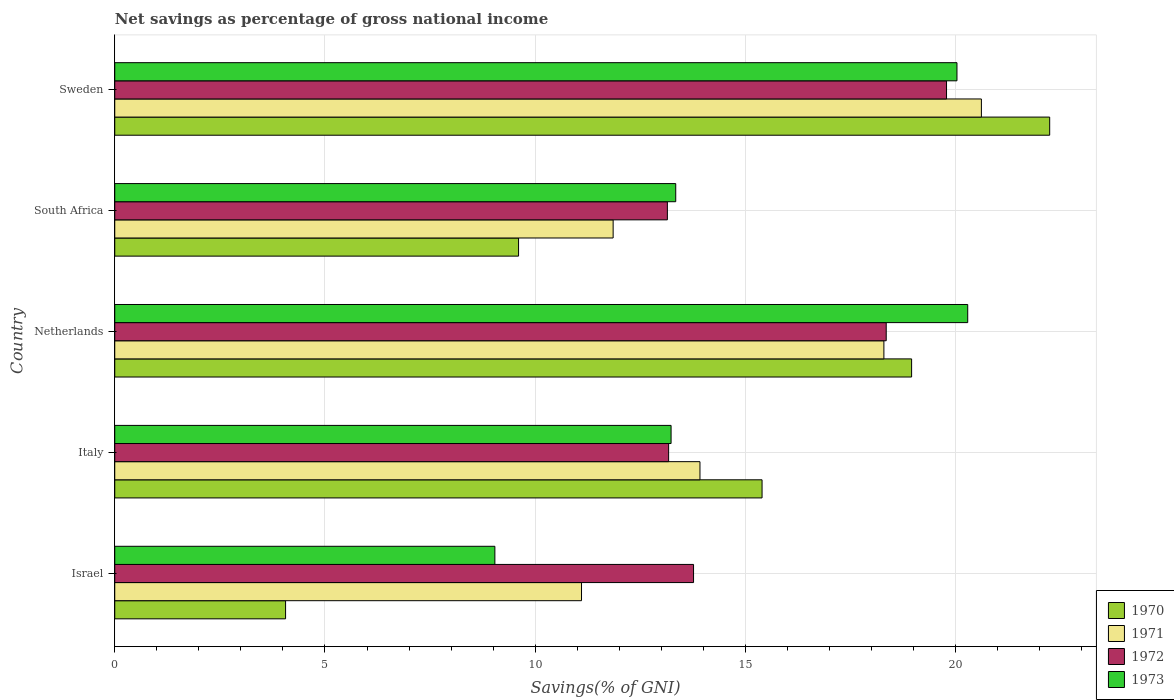How many groups of bars are there?
Your answer should be compact. 5. How many bars are there on the 5th tick from the bottom?
Your response must be concise. 4. What is the label of the 2nd group of bars from the top?
Keep it short and to the point. South Africa. In how many cases, is the number of bars for a given country not equal to the number of legend labels?
Your response must be concise. 0. What is the total savings in 1971 in Sweden?
Offer a very short reply. 20.61. Across all countries, what is the maximum total savings in 1972?
Give a very brief answer. 19.78. Across all countries, what is the minimum total savings in 1973?
Your answer should be very brief. 9.04. What is the total total savings in 1972 in the graph?
Your answer should be very brief. 78.22. What is the difference between the total savings in 1972 in Italy and that in South Africa?
Offer a terse response. 0.03. What is the difference between the total savings in 1972 in Italy and the total savings in 1970 in Israel?
Provide a succinct answer. 9.11. What is the average total savings in 1973 per country?
Ensure brevity in your answer.  15.19. What is the difference between the total savings in 1972 and total savings in 1973 in Italy?
Provide a short and direct response. -0.06. What is the ratio of the total savings in 1971 in Italy to that in Sweden?
Offer a very short reply. 0.68. What is the difference between the highest and the second highest total savings in 1973?
Make the answer very short. 0.26. What is the difference between the highest and the lowest total savings in 1972?
Your response must be concise. 6.64. In how many countries, is the total savings in 1970 greater than the average total savings in 1970 taken over all countries?
Give a very brief answer. 3. Is the sum of the total savings in 1971 in Israel and Italy greater than the maximum total savings in 1973 across all countries?
Keep it short and to the point. Yes. Is it the case that in every country, the sum of the total savings in 1971 and total savings in 1972 is greater than the sum of total savings in 1973 and total savings in 1970?
Offer a very short reply. No. What does the 2nd bar from the top in Netherlands represents?
Your answer should be very brief. 1972. Is it the case that in every country, the sum of the total savings in 1970 and total savings in 1971 is greater than the total savings in 1973?
Provide a succinct answer. Yes. How many bars are there?
Provide a succinct answer. 20. How many countries are there in the graph?
Offer a terse response. 5. Does the graph contain any zero values?
Provide a succinct answer. No. Does the graph contain grids?
Provide a succinct answer. Yes. What is the title of the graph?
Keep it short and to the point. Net savings as percentage of gross national income. Does "1976" appear as one of the legend labels in the graph?
Your answer should be compact. No. What is the label or title of the X-axis?
Your answer should be compact. Savings(% of GNI). What is the Savings(% of GNI) in 1970 in Israel?
Provide a succinct answer. 4.06. What is the Savings(% of GNI) of 1971 in Israel?
Provide a succinct answer. 11.1. What is the Savings(% of GNI) in 1972 in Israel?
Offer a very short reply. 13.77. What is the Savings(% of GNI) in 1973 in Israel?
Your answer should be compact. 9.04. What is the Savings(% of GNI) of 1970 in Italy?
Your answer should be compact. 15.4. What is the Savings(% of GNI) of 1971 in Italy?
Your response must be concise. 13.92. What is the Savings(% of GNI) in 1972 in Italy?
Your answer should be compact. 13.17. What is the Savings(% of GNI) in 1973 in Italy?
Your answer should be compact. 13.23. What is the Savings(% of GNI) of 1970 in Netherlands?
Ensure brevity in your answer.  18.95. What is the Savings(% of GNI) of 1971 in Netherlands?
Provide a succinct answer. 18.29. What is the Savings(% of GNI) of 1972 in Netherlands?
Provide a short and direct response. 18.35. What is the Savings(% of GNI) of 1973 in Netherlands?
Provide a succinct answer. 20.29. What is the Savings(% of GNI) in 1970 in South Africa?
Ensure brevity in your answer.  9.6. What is the Savings(% of GNI) in 1971 in South Africa?
Your answer should be very brief. 11.85. What is the Savings(% of GNI) in 1972 in South Africa?
Provide a short and direct response. 13.14. What is the Savings(% of GNI) in 1973 in South Africa?
Keep it short and to the point. 13.34. What is the Savings(% of GNI) in 1970 in Sweden?
Offer a terse response. 22.24. What is the Savings(% of GNI) in 1971 in Sweden?
Your response must be concise. 20.61. What is the Savings(% of GNI) in 1972 in Sweden?
Provide a succinct answer. 19.78. What is the Savings(% of GNI) of 1973 in Sweden?
Offer a terse response. 20.03. Across all countries, what is the maximum Savings(% of GNI) of 1970?
Give a very brief answer. 22.24. Across all countries, what is the maximum Savings(% of GNI) in 1971?
Your response must be concise. 20.61. Across all countries, what is the maximum Savings(% of GNI) of 1972?
Your answer should be compact. 19.78. Across all countries, what is the maximum Savings(% of GNI) in 1973?
Make the answer very short. 20.29. Across all countries, what is the minimum Savings(% of GNI) of 1970?
Your answer should be compact. 4.06. Across all countries, what is the minimum Savings(% of GNI) in 1971?
Give a very brief answer. 11.1. Across all countries, what is the minimum Savings(% of GNI) in 1972?
Your response must be concise. 13.14. Across all countries, what is the minimum Savings(% of GNI) of 1973?
Keep it short and to the point. 9.04. What is the total Savings(% of GNI) of 1970 in the graph?
Make the answer very short. 70.25. What is the total Savings(% of GNI) of 1971 in the graph?
Provide a short and direct response. 75.78. What is the total Savings(% of GNI) in 1972 in the graph?
Your answer should be compact. 78.22. What is the total Savings(% of GNI) in 1973 in the graph?
Provide a short and direct response. 75.93. What is the difference between the Savings(% of GNI) of 1970 in Israel and that in Italy?
Provide a short and direct response. -11.33. What is the difference between the Savings(% of GNI) of 1971 in Israel and that in Italy?
Your response must be concise. -2.82. What is the difference between the Savings(% of GNI) in 1972 in Israel and that in Italy?
Your response must be concise. 0.59. What is the difference between the Savings(% of GNI) of 1973 in Israel and that in Italy?
Your answer should be compact. -4.19. What is the difference between the Savings(% of GNI) of 1970 in Israel and that in Netherlands?
Your answer should be compact. -14.89. What is the difference between the Savings(% of GNI) of 1971 in Israel and that in Netherlands?
Make the answer very short. -7.19. What is the difference between the Savings(% of GNI) of 1972 in Israel and that in Netherlands?
Keep it short and to the point. -4.58. What is the difference between the Savings(% of GNI) in 1973 in Israel and that in Netherlands?
Make the answer very short. -11.25. What is the difference between the Savings(% of GNI) in 1970 in Israel and that in South Africa?
Make the answer very short. -5.54. What is the difference between the Savings(% of GNI) in 1971 in Israel and that in South Africa?
Give a very brief answer. -0.75. What is the difference between the Savings(% of GNI) in 1972 in Israel and that in South Africa?
Offer a terse response. 0.62. What is the difference between the Savings(% of GNI) in 1973 in Israel and that in South Africa?
Your answer should be compact. -4.3. What is the difference between the Savings(% of GNI) in 1970 in Israel and that in Sweden?
Make the answer very short. -18.17. What is the difference between the Savings(% of GNI) of 1971 in Israel and that in Sweden?
Keep it short and to the point. -9.51. What is the difference between the Savings(% of GNI) of 1972 in Israel and that in Sweden?
Ensure brevity in your answer.  -6.02. What is the difference between the Savings(% of GNI) of 1973 in Israel and that in Sweden?
Make the answer very short. -10.99. What is the difference between the Savings(% of GNI) in 1970 in Italy and that in Netherlands?
Your answer should be compact. -3.56. What is the difference between the Savings(% of GNI) of 1971 in Italy and that in Netherlands?
Keep it short and to the point. -4.37. What is the difference between the Savings(% of GNI) in 1972 in Italy and that in Netherlands?
Your answer should be very brief. -5.18. What is the difference between the Savings(% of GNI) of 1973 in Italy and that in Netherlands?
Provide a short and direct response. -7.06. What is the difference between the Savings(% of GNI) in 1970 in Italy and that in South Africa?
Keep it short and to the point. 5.79. What is the difference between the Savings(% of GNI) of 1971 in Italy and that in South Africa?
Offer a terse response. 2.07. What is the difference between the Savings(% of GNI) in 1972 in Italy and that in South Africa?
Ensure brevity in your answer.  0.03. What is the difference between the Savings(% of GNI) of 1973 in Italy and that in South Africa?
Your answer should be compact. -0.11. What is the difference between the Savings(% of GNI) of 1970 in Italy and that in Sweden?
Make the answer very short. -6.84. What is the difference between the Savings(% of GNI) of 1971 in Italy and that in Sweden?
Provide a short and direct response. -6.69. What is the difference between the Savings(% of GNI) of 1972 in Italy and that in Sweden?
Ensure brevity in your answer.  -6.61. What is the difference between the Savings(% of GNI) in 1973 in Italy and that in Sweden?
Provide a succinct answer. -6.8. What is the difference between the Savings(% of GNI) of 1970 in Netherlands and that in South Africa?
Offer a terse response. 9.35. What is the difference between the Savings(% of GNI) in 1971 in Netherlands and that in South Africa?
Give a very brief answer. 6.44. What is the difference between the Savings(% of GNI) of 1972 in Netherlands and that in South Africa?
Offer a terse response. 5.21. What is the difference between the Savings(% of GNI) of 1973 in Netherlands and that in South Africa?
Your answer should be compact. 6.95. What is the difference between the Savings(% of GNI) in 1970 in Netherlands and that in Sweden?
Offer a terse response. -3.28. What is the difference between the Savings(% of GNI) in 1971 in Netherlands and that in Sweden?
Your answer should be compact. -2.32. What is the difference between the Savings(% of GNI) of 1972 in Netherlands and that in Sweden?
Your answer should be very brief. -1.43. What is the difference between the Savings(% of GNI) of 1973 in Netherlands and that in Sweden?
Make the answer very short. 0.26. What is the difference between the Savings(% of GNI) of 1970 in South Africa and that in Sweden?
Offer a terse response. -12.63. What is the difference between the Savings(% of GNI) of 1971 in South Africa and that in Sweden?
Keep it short and to the point. -8.76. What is the difference between the Savings(% of GNI) of 1972 in South Africa and that in Sweden?
Offer a very short reply. -6.64. What is the difference between the Savings(% of GNI) in 1973 in South Africa and that in Sweden?
Provide a short and direct response. -6.69. What is the difference between the Savings(% of GNI) of 1970 in Israel and the Savings(% of GNI) of 1971 in Italy?
Your answer should be compact. -9.86. What is the difference between the Savings(% of GNI) in 1970 in Israel and the Savings(% of GNI) in 1972 in Italy?
Give a very brief answer. -9.11. What is the difference between the Savings(% of GNI) in 1970 in Israel and the Savings(% of GNI) in 1973 in Italy?
Ensure brevity in your answer.  -9.17. What is the difference between the Savings(% of GNI) of 1971 in Israel and the Savings(% of GNI) of 1972 in Italy?
Make the answer very short. -2.07. What is the difference between the Savings(% of GNI) in 1971 in Israel and the Savings(% of GNI) in 1973 in Italy?
Your response must be concise. -2.13. What is the difference between the Savings(% of GNI) in 1972 in Israel and the Savings(% of GNI) in 1973 in Italy?
Make the answer very short. 0.53. What is the difference between the Savings(% of GNI) in 1970 in Israel and the Savings(% of GNI) in 1971 in Netherlands?
Provide a succinct answer. -14.23. What is the difference between the Savings(% of GNI) of 1970 in Israel and the Savings(% of GNI) of 1972 in Netherlands?
Give a very brief answer. -14.29. What is the difference between the Savings(% of GNI) of 1970 in Israel and the Savings(% of GNI) of 1973 in Netherlands?
Offer a terse response. -16.22. What is the difference between the Savings(% of GNI) in 1971 in Israel and the Savings(% of GNI) in 1972 in Netherlands?
Your answer should be compact. -7.25. What is the difference between the Savings(% of GNI) in 1971 in Israel and the Savings(% of GNI) in 1973 in Netherlands?
Make the answer very short. -9.19. What is the difference between the Savings(% of GNI) of 1972 in Israel and the Savings(% of GNI) of 1973 in Netherlands?
Offer a very short reply. -6.52. What is the difference between the Savings(% of GNI) in 1970 in Israel and the Savings(% of GNI) in 1971 in South Africa?
Keep it short and to the point. -7.79. What is the difference between the Savings(% of GNI) in 1970 in Israel and the Savings(% of GNI) in 1972 in South Africa?
Give a very brief answer. -9.08. What is the difference between the Savings(% of GNI) in 1970 in Israel and the Savings(% of GNI) in 1973 in South Africa?
Provide a succinct answer. -9.28. What is the difference between the Savings(% of GNI) of 1971 in Israel and the Savings(% of GNI) of 1972 in South Africa?
Provide a succinct answer. -2.04. What is the difference between the Savings(% of GNI) of 1971 in Israel and the Savings(% of GNI) of 1973 in South Africa?
Ensure brevity in your answer.  -2.24. What is the difference between the Savings(% of GNI) in 1972 in Israel and the Savings(% of GNI) in 1973 in South Africa?
Your response must be concise. 0.42. What is the difference between the Savings(% of GNI) in 1970 in Israel and the Savings(% of GNI) in 1971 in Sweden?
Your answer should be compact. -16.55. What is the difference between the Savings(% of GNI) of 1970 in Israel and the Savings(% of GNI) of 1972 in Sweden?
Offer a terse response. -15.72. What is the difference between the Savings(% of GNI) in 1970 in Israel and the Savings(% of GNI) in 1973 in Sweden?
Offer a terse response. -15.97. What is the difference between the Savings(% of GNI) in 1971 in Israel and the Savings(% of GNI) in 1972 in Sweden?
Offer a very short reply. -8.68. What is the difference between the Savings(% of GNI) of 1971 in Israel and the Savings(% of GNI) of 1973 in Sweden?
Your answer should be very brief. -8.93. What is the difference between the Savings(% of GNI) of 1972 in Israel and the Savings(% of GNI) of 1973 in Sweden?
Make the answer very short. -6.27. What is the difference between the Savings(% of GNI) in 1970 in Italy and the Savings(% of GNI) in 1971 in Netherlands?
Your answer should be compact. -2.9. What is the difference between the Savings(% of GNI) of 1970 in Italy and the Savings(% of GNI) of 1972 in Netherlands?
Make the answer very short. -2.95. What is the difference between the Savings(% of GNI) of 1970 in Italy and the Savings(% of GNI) of 1973 in Netherlands?
Offer a terse response. -4.89. What is the difference between the Savings(% of GNI) of 1971 in Italy and the Savings(% of GNI) of 1972 in Netherlands?
Your answer should be compact. -4.43. What is the difference between the Savings(% of GNI) of 1971 in Italy and the Savings(% of GNI) of 1973 in Netherlands?
Provide a succinct answer. -6.37. What is the difference between the Savings(% of GNI) of 1972 in Italy and the Savings(% of GNI) of 1973 in Netherlands?
Give a very brief answer. -7.11. What is the difference between the Savings(% of GNI) of 1970 in Italy and the Savings(% of GNI) of 1971 in South Africa?
Keep it short and to the point. 3.54. What is the difference between the Savings(% of GNI) in 1970 in Italy and the Savings(% of GNI) in 1972 in South Africa?
Provide a short and direct response. 2.25. What is the difference between the Savings(% of GNI) of 1970 in Italy and the Savings(% of GNI) of 1973 in South Africa?
Ensure brevity in your answer.  2.05. What is the difference between the Savings(% of GNI) of 1971 in Italy and the Savings(% of GNI) of 1972 in South Africa?
Your answer should be compact. 0.78. What is the difference between the Savings(% of GNI) in 1971 in Italy and the Savings(% of GNI) in 1973 in South Africa?
Provide a short and direct response. 0.58. What is the difference between the Savings(% of GNI) of 1972 in Italy and the Savings(% of GNI) of 1973 in South Africa?
Keep it short and to the point. -0.17. What is the difference between the Savings(% of GNI) of 1970 in Italy and the Savings(% of GNI) of 1971 in Sweden?
Ensure brevity in your answer.  -5.22. What is the difference between the Savings(% of GNI) of 1970 in Italy and the Savings(% of GNI) of 1972 in Sweden?
Make the answer very short. -4.39. What is the difference between the Savings(% of GNI) in 1970 in Italy and the Savings(% of GNI) in 1973 in Sweden?
Ensure brevity in your answer.  -4.64. What is the difference between the Savings(% of GNI) in 1971 in Italy and the Savings(% of GNI) in 1972 in Sweden?
Give a very brief answer. -5.86. What is the difference between the Savings(% of GNI) of 1971 in Italy and the Savings(% of GNI) of 1973 in Sweden?
Give a very brief answer. -6.11. What is the difference between the Savings(% of GNI) of 1972 in Italy and the Savings(% of GNI) of 1973 in Sweden?
Your answer should be compact. -6.86. What is the difference between the Savings(% of GNI) in 1970 in Netherlands and the Savings(% of GNI) in 1971 in South Africa?
Provide a succinct answer. 7.1. What is the difference between the Savings(% of GNI) in 1970 in Netherlands and the Savings(% of GNI) in 1972 in South Africa?
Ensure brevity in your answer.  5.81. What is the difference between the Savings(% of GNI) in 1970 in Netherlands and the Savings(% of GNI) in 1973 in South Africa?
Offer a very short reply. 5.61. What is the difference between the Savings(% of GNI) of 1971 in Netherlands and the Savings(% of GNI) of 1972 in South Africa?
Your answer should be compact. 5.15. What is the difference between the Savings(% of GNI) of 1971 in Netherlands and the Savings(% of GNI) of 1973 in South Africa?
Ensure brevity in your answer.  4.95. What is the difference between the Savings(% of GNI) of 1972 in Netherlands and the Savings(% of GNI) of 1973 in South Africa?
Your answer should be compact. 5.01. What is the difference between the Savings(% of GNI) of 1970 in Netherlands and the Savings(% of GNI) of 1971 in Sweden?
Ensure brevity in your answer.  -1.66. What is the difference between the Savings(% of GNI) of 1970 in Netherlands and the Savings(% of GNI) of 1972 in Sweden?
Keep it short and to the point. -0.83. What is the difference between the Savings(% of GNI) of 1970 in Netherlands and the Savings(% of GNI) of 1973 in Sweden?
Offer a very short reply. -1.08. What is the difference between the Savings(% of GNI) in 1971 in Netherlands and the Savings(% of GNI) in 1972 in Sweden?
Provide a short and direct response. -1.49. What is the difference between the Savings(% of GNI) in 1971 in Netherlands and the Savings(% of GNI) in 1973 in Sweden?
Give a very brief answer. -1.74. What is the difference between the Savings(% of GNI) in 1972 in Netherlands and the Savings(% of GNI) in 1973 in Sweden?
Offer a very short reply. -1.68. What is the difference between the Savings(% of GNI) in 1970 in South Africa and the Savings(% of GNI) in 1971 in Sweden?
Offer a terse response. -11.01. What is the difference between the Savings(% of GNI) of 1970 in South Africa and the Savings(% of GNI) of 1972 in Sweden?
Provide a succinct answer. -10.18. What is the difference between the Savings(% of GNI) in 1970 in South Africa and the Savings(% of GNI) in 1973 in Sweden?
Offer a terse response. -10.43. What is the difference between the Savings(% of GNI) of 1971 in South Africa and the Savings(% of GNI) of 1972 in Sweden?
Your answer should be compact. -7.93. What is the difference between the Savings(% of GNI) of 1971 in South Africa and the Savings(% of GNI) of 1973 in Sweden?
Your answer should be very brief. -8.18. What is the difference between the Savings(% of GNI) of 1972 in South Africa and the Savings(% of GNI) of 1973 in Sweden?
Make the answer very short. -6.89. What is the average Savings(% of GNI) in 1970 per country?
Your response must be concise. 14.05. What is the average Savings(% of GNI) of 1971 per country?
Keep it short and to the point. 15.16. What is the average Savings(% of GNI) of 1972 per country?
Offer a terse response. 15.64. What is the average Savings(% of GNI) of 1973 per country?
Offer a very short reply. 15.19. What is the difference between the Savings(% of GNI) in 1970 and Savings(% of GNI) in 1971 in Israel?
Offer a very short reply. -7.04. What is the difference between the Savings(% of GNI) of 1970 and Savings(% of GNI) of 1972 in Israel?
Ensure brevity in your answer.  -9.7. What is the difference between the Savings(% of GNI) of 1970 and Savings(% of GNI) of 1973 in Israel?
Provide a short and direct response. -4.98. What is the difference between the Savings(% of GNI) in 1971 and Savings(% of GNI) in 1972 in Israel?
Your answer should be very brief. -2.66. What is the difference between the Savings(% of GNI) in 1971 and Savings(% of GNI) in 1973 in Israel?
Give a very brief answer. 2.06. What is the difference between the Savings(% of GNI) of 1972 and Savings(% of GNI) of 1973 in Israel?
Give a very brief answer. 4.73. What is the difference between the Savings(% of GNI) in 1970 and Savings(% of GNI) in 1971 in Italy?
Provide a short and direct response. 1.48. What is the difference between the Savings(% of GNI) of 1970 and Savings(% of GNI) of 1972 in Italy?
Give a very brief answer. 2.22. What is the difference between the Savings(% of GNI) in 1970 and Savings(% of GNI) in 1973 in Italy?
Ensure brevity in your answer.  2.16. What is the difference between the Savings(% of GNI) in 1971 and Savings(% of GNI) in 1972 in Italy?
Offer a very short reply. 0.75. What is the difference between the Savings(% of GNI) in 1971 and Savings(% of GNI) in 1973 in Italy?
Ensure brevity in your answer.  0.69. What is the difference between the Savings(% of GNI) in 1972 and Savings(% of GNI) in 1973 in Italy?
Your answer should be compact. -0.06. What is the difference between the Savings(% of GNI) of 1970 and Savings(% of GNI) of 1971 in Netherlands?
Give a very brief answer. 0.66. What is the difference between the Savings(% of GNI) of 1970 and Savings(% of GNI) of 1972 in Netherlands?
Provide a succinct answer. 0.6. What is the difference between the Savings(% of GNI) in 1970 and Savings(% of GNI) in 1973 in Netherlands?
Your answer should be very brief. -1.33. What is the difference between the Savings(% of GNI) in 1971 and Savings(% of GNI) in 1972 in Netherlands?
Give a very brief answer. -0.06. What is the difference between the Savings(% of GNI) of 1971 and Savings(% of GNI) of 1973 in Netherlands?
Your answer should be very brief. -1.99. What is the difference between the Savings(% of GNI) in 1972 and Savings(% of GNI) in 1973 in Netherlands?
Make the answer very short. -1.94. What is the difference between the Savings(% of GNI) of 1970 and Savings(% of GNI) of 1971 in South Africa?
Ensure brevity in your answer.  -2.25. What is the difference between the Savings(% of GNI) of 1970 and Savings(% of GNI) of 1972 in South Africa?
Offer a very short reply. -3.54. What is the difference between the Savings(% of GNI) in 1970 and Savings(% of GNI) in 1973 in South Africa?
Give a very brief answer. -3.74. What is the difference between the Savings(% of GNI) in 1971 and Savings(% of GNI) in 1972 in South Africa?
Offer a terse response. -1.29. What is the difference between the Savings(% of GNI) in 1971 and Savings(% of GNI) in 1973 in South Africa?
Your answer should be compact. -1.49. What is the difference between the Savings(% of GNI) in 1972 and Savings(% of GNI) in 1973 in South Africa?
Ensure brevity in your answer.  -0.2. What is the difference between the Savings(% of GNI) of 1970 and Savings(% of GNI) of 1971 in Sweden?
Your answer should be very brief. 1.62. What is the difference between the Savings(% of GNI) in 1970 and Savings(% of GNI) in 1972 in Sweden?
Offer a very short reply. 2.45. What is the difference between the Savings(% of GNI) of 1970 and Savings(% of GNI) of 1973 in Sweden?
Your answer should be very brief. 2.21. What is the difference between the Savings(% of GNI) of 1971 and Savings(% of GNI) of 1972 in Sweden?
Give a very brief answer. 0.83. What is the difference between the Savings(% of GNI) in 1971 and Savings(% of GNI) in 1973 in Sweden?
Provide a succinct answer. 0.58. What is the difference between the Savings(% of GNI) of 1972 and Savings(% of GNI) of 1973 in Sweden?
Provide a short and direct response. -0.25. What is the ratio of the Savings(% of GNI) of 1970 in Israel to that in Italy?
Offer a very short reply. 0.26. What is the ratio of the Savings(% of GNI) of 1971 in Israel to that in Italy?
Ensure brevity in your answer.  0.8. What is the ratio of the Savings(% of GNI) in 1972 in Israel to that in Italy?
Make the answer very short. 1.04. What is the ratio of the Savings(% of GNI) of 1973 in Israel to that in Italy?
Offer a very short reply. 0.68. What is the ratio of the Savings(% of GNI) in 1970 in Israel to that in Netherlands?
Your answer should be very brief. 0.21. What is the ratio of the Savings(% of GNI) of 1971 in Israel to that in Netherlands?
Make the answer very short. 0.61. What is the ratio of the Savings(% of GNI) in 1972 in Israel to that in Netherlands?
Make the answer very short. 0.75. What is the ratio of the Savings(% of GNI) of 1973 in Israel to that in Netherlands?
Ensure brevity in your answer.  0.45. What is the ratio of the Savings(% of GNI) of 1970 in Israel to that in South Africa?
Make the answer very short. 0.42. What is the ratio of the Savings(% of GNI) in 1971 in Israel to that in South Africa?
Keep it short and to the point. 0.94. What is the ratio of the Savings(% of GNI) in 1972 in Israel to that in South Africa?
Give a very brief answer. 1.05. What is the ratio of the Savings(% of GNI) of 1973 in Israel to that in South Africa?
Provide a short and direct response. 0.68. What is the ratio of the Savings(% of GNI) in 1970 in Israel to that in Sweden?
Provide a short and direct response. 0.18. What is the ratio of the Savings(% of GNI) in 1971 in Israel to that in Sweden?
Offer a terse response. 0.54. What is the ratio of the Savings(% of GNI) of 1972 in Israel to that in Sweden?
Make the answer very short. 0.7. What is the ratio of the Savings(% of GNI) of 1973 in Israel to that in Sweden?
Your answer should be compact. 0.45. What is the ratio of the Savings(% of GNI) in 1970 in Italy to that in Netherlands?
Your answer should be very brief. 0.81. What is the ratio of the Savings(% of GNI) of 1971 in Italy to that in Netherlands?
Offer a terse response. 0.76. What is the ratio of the Savings(% of GNI) of 1972 in Italy to that in Netherlands?
Provide a short and direct response. 0.72. What is the ratio of the Savings(% of GNI) in 1973 in Italy to that in Netherlands?
Offer a terse response. 0.65. What is the ratio of the Savings(% of GNI) in 1970 in Italy to that in South Africa?
Your response must be concise. 1.6. What is the ratio of the Savings(% of GNI) of 1971 in Italy to that in South Africa?
Offer a very short reply. 1.17. What is the ratio of the Savings(% of GNI) of 1972 in Italy to that in South Africa?
Make the answer very short. 1. What is the ratio of the Savings(% of GNI) in 1973 in Italy to that in South Africa?
Provide a short and direct response. 0.99. What is the ratio of the Savings(% of GNI) of 1970 in Italy to that in Sweden?
Provide a short and direct response. 0.69. What is the ratio of the Savings(% of GNI) of 1971 in Italy to that in Sweden?
Ensure brevity in your answer.  0.68. What is the ratio of the Savings(% of GNI) of 1972 in Italy to that in Sweden?
Offer a terse response. 0.67. What is the ratio of the Savings(% of GNI) in 1973 in Italy to that in Sweden?
Keep it short and to the point. 0.66. What is the ratio of the Savings(% of GNI) in 1970 in Netherlands to that in South Africa?
Your answer should be very brief. 1.97. What is the ratio of the Savings(% of GNI) of 1971 in Netherlands to that in South Africa?
Your answer should be compact. 1.54. What is the ratio of the Savings(% of GNI) in 1972 in Netherlands to that in South Africa?
Provide a short and direct response. 1.4. What is the ratio of the Savings(% of GNI) of 1973 in Netherlands to that in South Africa?
Provide a succinct answer. 1.52. What is the ratio of the Savings(% of GNI) in 1970 in Netherlands to that in Sweden?
Offer a very short reply. 0.85. What is the ratio of the Savings(% of GNI) of 1971 in Netherlands to that in Sweden?
Keep it short and to the point. 0.89. What is the ratio of the Savings(% of GNI) of 1972 in Netherlands to that in Sweden?
Your response must be concise. 0.93. What is the ratio of the Savings(% of GNI) of 1973 in Netherlands to that in Sweden?
Provide a short and direct response. 1.01. What is the ratio of the Savings(% of GNI) in 1970 in South Africa to that in Sweden?
Make the answer very short. 0.43. What is the ratio of the Savings(% of GNI) in 1971 in South Africa to that in Sweden?
Provide a succinct answer. 0.58. What is the ratio of the Savings(% of GNI) of 1972 in South Africa to that in Sweden?
Your response must be concise. 0.66. What is the ratio of the Savings(% of GNI) of 1973 in South Africa to that in Sweden?
Ensure brevity in your answer.  0.67. What is the difference between the highest and the second highest Savings(% of GNI) in 1970?
Ensure brevity in your answer.  3.28. What is the difference between the highest and the second highest Savings(% of GNI) in 1971?
Give a very brief answer. 2.32. What is the difference between the highest and the second highest Savings(% of GNI) in 1972?
Keep it short and to the point. 1.43. What is the difference between the highest and the second highest Savings(% of GNI) of 1973?
Ensure brevity in your answer.  0.26. What is the difference between the highest and the lowest Savings(% of GNI) of 1970?
Your answer should be compact. 18.17. What is the difference between the highest and the lowest Savings(% of GNI) in 1971?
Your answer should be very brief. 9.51. What is the difference between the highest and the lowest Savings(% of GNI) of 1972?
Provide a succinct answer. 6.64. What is the difference between the highest and the lowest Savings(% of GNI) in 1973?
Ensure brevity in your answer.  11.25. 